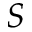<formula> <loc_0><loc_0><loc_500><loc_500>S</formula> 